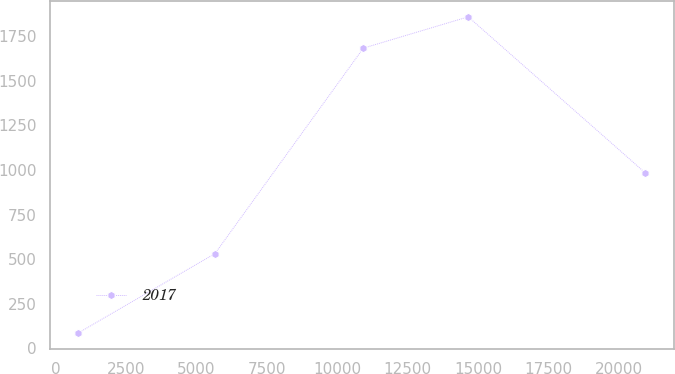Convert chart to OTSL. <chart><loc_0><loc_0><loc_500><loc_500><line_chart><ecel><fcel>2017<nl><fcel>801.85<fcel>86.25<nl><fcel>5656.68<fcel>531.1<nl><fcel>10923.8<fcel>1682.6<nl><fcel>14646.7<fcel>1858.19<nl><fcel>20934.3<fcel>983.21<nl></chart> 